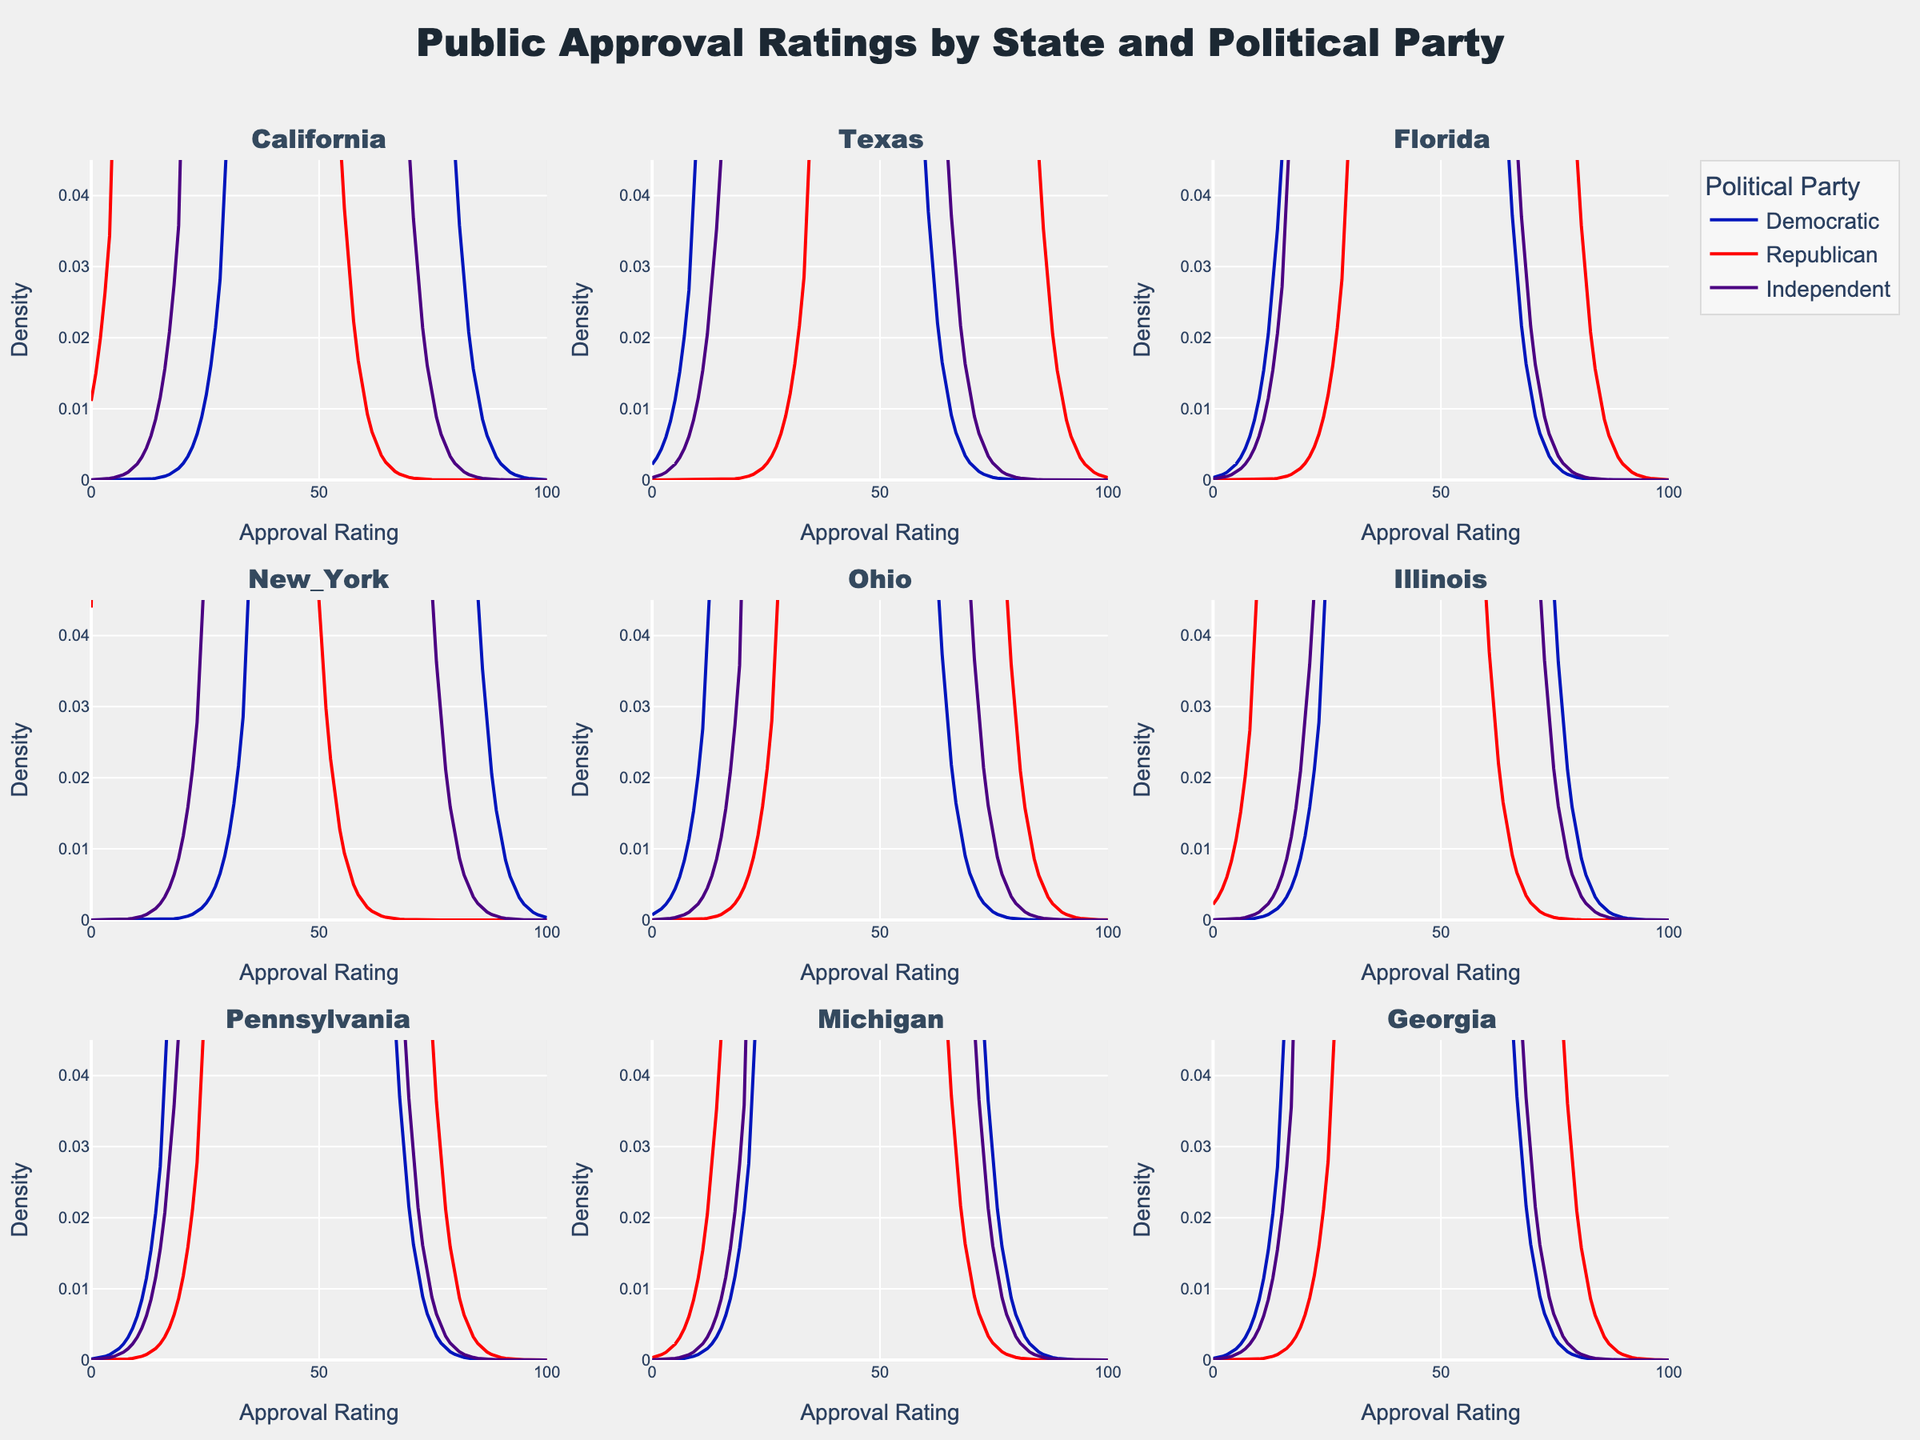What is the title of the plot? The title is located at the top center of the plot and is designed to provide an overview of the figure. The title text helps the viewer understand the general topic being visualized.
Answer: Public Approval Ratings by State and Political Party How many states are displayed in the figure? By counting the subplot titles which are aligned with the states, we can determine the number of states visualized.
Answer: 8 In which state do Independents have the highest approval rating? To find this, look at each subplot and identify the highest peak density line for Independents. The state with the highest y-value in the Independent category indicates the highest approval rating.
Answer: New York Which political party has the highest approval rating in Texas? In the Texas subplot, compare the peaks of the density lines for all political parties. The line with the highest peak represents the highest approval rating.
Answer: Republican How do the approval ratings for Democrats in California compare to Republicans in California? To compare, look at the peaks of the density lines for Democrats and Republicans in the California subplot. The Democratic line appears higher, indicating a higher approval rating.
Answer: Democrats have a higher approval rating What is the approval rating range shown on the x-axis? The x-axis title is "Approval Rating" with the range starting from 0 to 100, as indicated by the axis ticks and labels on the figure.
Answer: 0 to 100 How does the approval rating shape of Independents in Georgia compare to Republicans in Georgia? By examining the Georgia subplot, notice the shape and peak of the density lines. Republicans show a higher peak compared to the more moderate density distribution of Independents.
Answer: Republicans have a distinctly higher and sharper peak Which state shows the least approval rating for Republicans? Reviewing the lowest peaks among Republican lines in each subplot reveals the state with the least approval rating. The Republican line for New York shows the lowest peak.
Answer: New York What does the y-axis title "Density" indicate in the context of this plot? The y-axis title "Density" helps understand that the plot shows the distribution of approval ratings in a probabilistic sense, where higher values indicate a higher concentration of approval ratings around certain points.
Answer: It indicates the distribution of approval ratings 